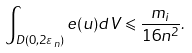Convert formula to latex. <formula><loc_0><loc_0><loc_500><loc_500>\int _ { D ( 0 , 2 \varepsilon _ { n } ) } e ( u ) d V \leqslant \frac { m _ { i } } { 1 6 n ^ { 2 } } .</formula> 